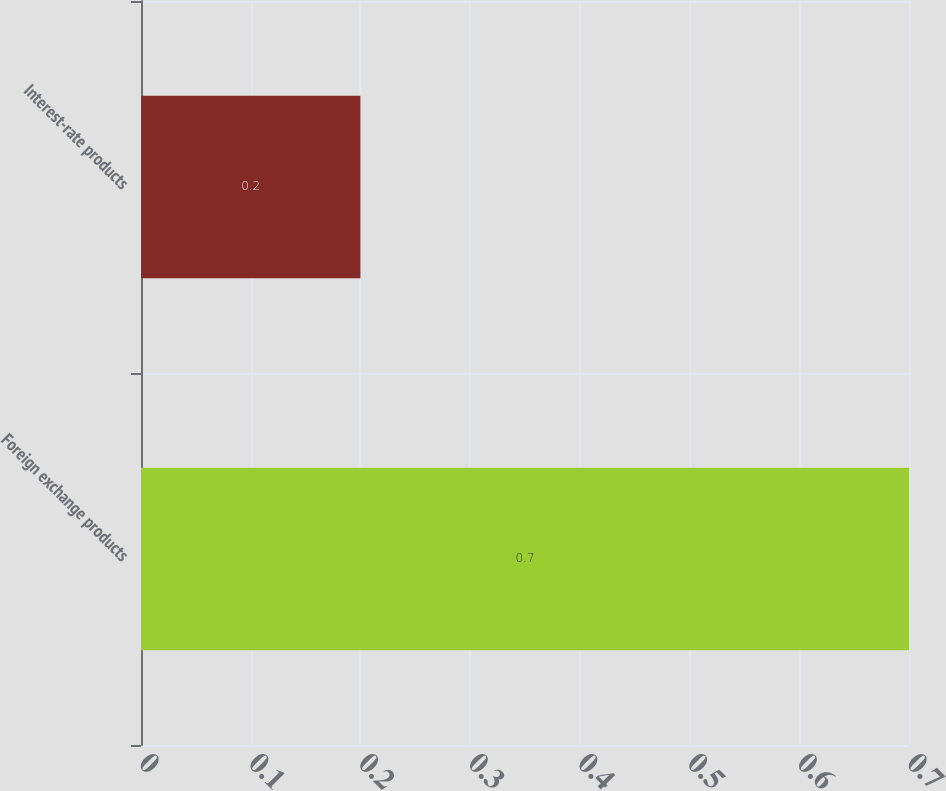Convert chart to OTSL. <chart><loc_0><loc_0><loc_500><loc_500><bar_chart><fcel>Foreign exchange products<fcel>Interest-rate products<nl><fcel>0.7<fcel>0.2<nl></chart> 